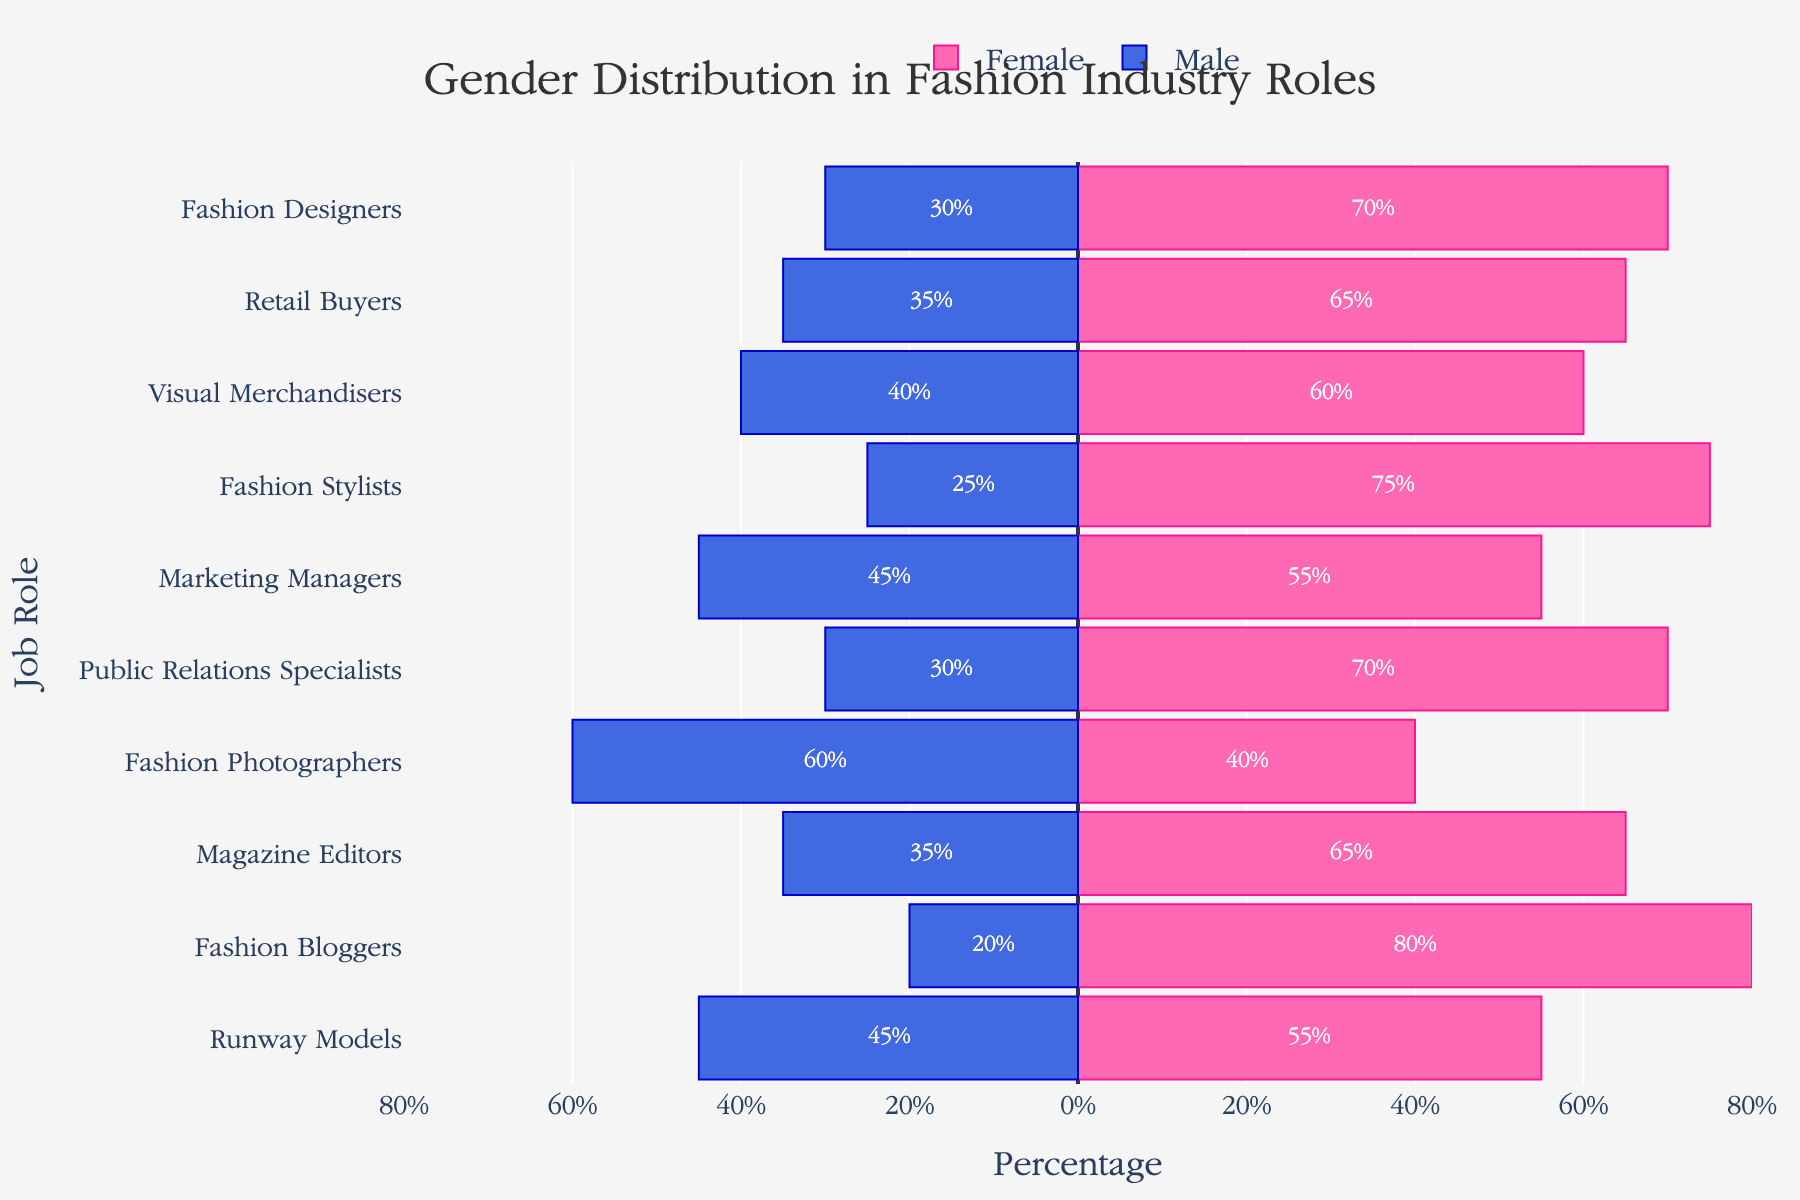Which job role has the highest percentage of females? The highest percentage of females can be determined by looking at the length of the pink bars, representing females, and finding the longest one. Fashion Bloggers has the highest percentage, with 80%.
Answer: Fashion Bloggers What's the gender breakdown for Fashion Designers? To find the gender breakdown, look at the lengths of the bars associated with Fashion Designers. The pink bar (Female) is 70% and the blue bar (Male) is 30%.
Answer: Male: 30%, Female: 70% Which job roles have an equal percentage of males and females? To find an equal percentage of males and females, look for bars of equal length on both sides. Runway Models has 45% males and 55% females, which is not equal. There are no job roles with equal gender percentages in this figure.
Answer: None Compare the percentages of males in the roles of Fashion Photographers and Magazine Editors. Which has a higher percentage and by how much? Fashion Photographers have 60% males, and Magazine Editors have 35% males. Subtracting these values gives the difference: 60% - 35% = 25%. So, Fashion Photographers have a higher percentage of males by 25%.
Answer: Fashion Photographers by 25% How does the percentage of females in Marketing Managers compare to that in Public Relations Specialists? Marketing Managers have 55% females, and Public Relations Specialists have 70% females. To compare, subtract the smaller percentage from the larger: 70% - 55% = 15%. So, Public Relations Specialists have 15% more females than Marketing Managers.
Answer: Public Relations Specialists by 15% What is the overall trend in gender distribution across most job roles? Observing the pattern of the bars, the figure predominantly shows longer pink bars (females) compared to blue bars (males), indicating that females generally make up a larger percentage across most job roles.
Answer: Females predominate Which job role has the smallest percentage of males? The smallest percentage of males can be identified by looking for the shortest blue bar. Fashion Bloggers have the smallest percentage of males at 20%.
Answer: Fashion Bloggers Is there any job role where males have a higher percentage than females? To determine this, look for job roles where the blue bar exceeds the pink bar in length. Fashion Photographers is the only role where males (60%) have a higher percentage than females (40%).
Answer: Fashion Photographers What is the percentage difference between males and females for Visual Merchandisers? Visual Merchandisers have 40% males and 60% females. To find the difference, subtract the male percentage from the female percentage: 60% - 40% = 20%.
Answer: 20% 